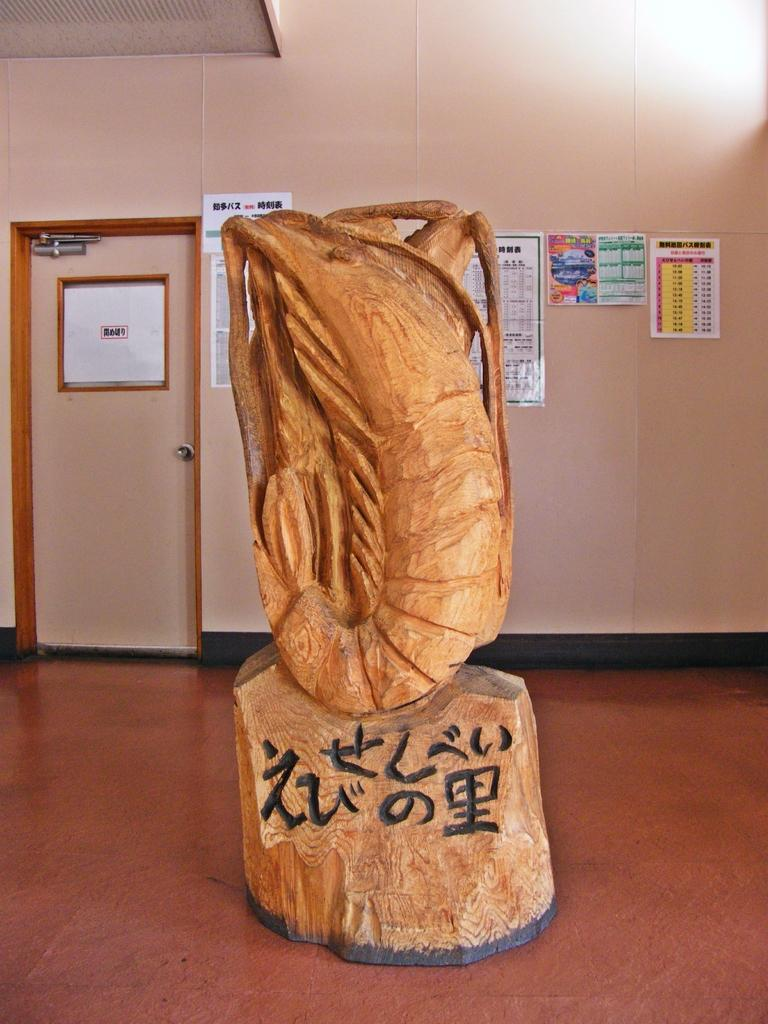<image>
Summarize the visual content of the image. A statue which has been carved out of wood has writing engraved under it in an Asian language. 